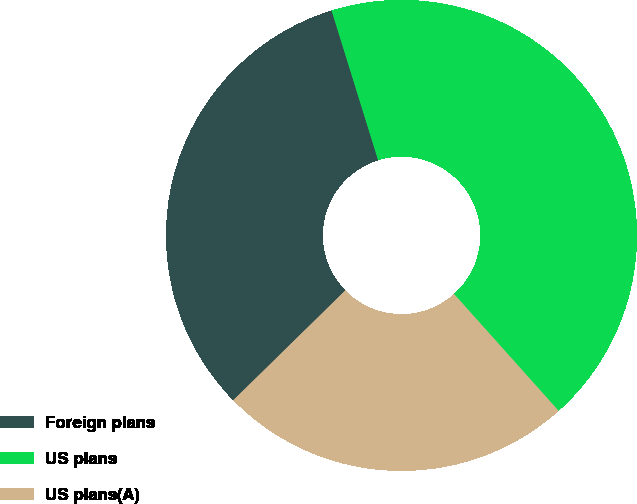Convert chart. <chart><loc_0><loc_0><loc_500><loc_500><pie_chart><fcel>Foreign plans<fcel>US plans<fcel>US plans(A)<nl><fcel>32.54%<fcel>43.17%<fcel>24.28%<nl></chart> 